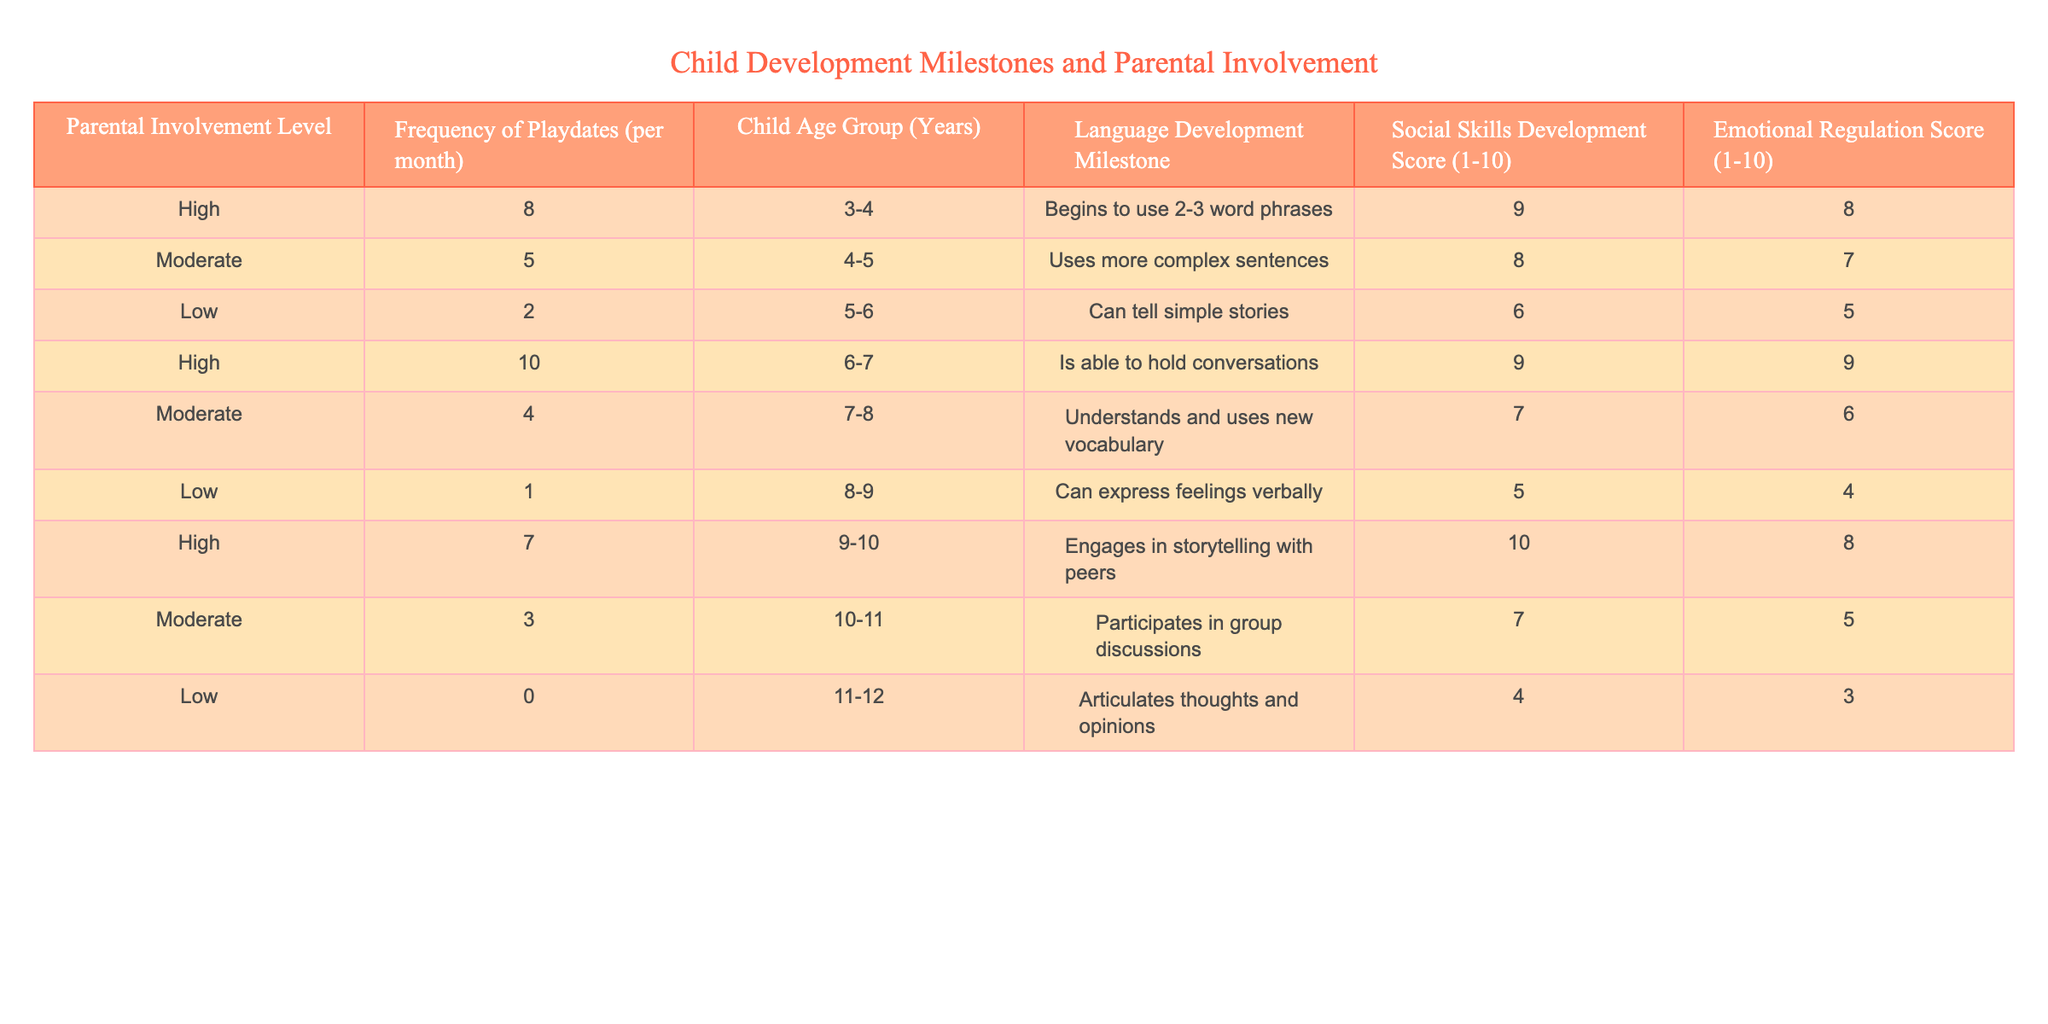What is the highest Social Skills Development Score recorded in the table? The maximum score in the "Social Skills Development Score" column is 10. This value is found in the row where the parental involvement level is "High," the frequency of playdates is 7, and the child age group is 9-10 years.
Answer: 10 What age group has the lowest Emotional Regulation Score? The "Emotional Regulation Score" for the age group 11-12, with low parental involvement and 0 playdates, is 3. This is the lowest score across all age groups in the table.
Answer: 3 What is the average frequency of playdates for children in the 3-4 age group? There is one entry for the 3-4 age group with 8 playdates per month. Therefore, the average is 8 since there's only one data point present.
Answer: 8 Did children with high parental involvement consistently have higher scores in language development compared to those with low involvement? Yes, children with high parental involvement had language development milestones such as using 2-3 word phrases and holding conversations, while those with low involvement showed lower milestones: they can only tell simple stories or express feelings verbally.
Answer: Yes What is the total number of playdates recorded for children in the 4-5 age group? There is one entry for the 4-5 age group with a frequency of 5 playdates per month. Therefore, the total for this age group is simply 5 playdates.
Answer: 5 What was the average Emotional Regulation Score for the moderate parental involvement level? The Emotional Regulation Scores for moderate involvement are 7, 6, and 5. Summing these gives 7 + 6 + 5 = 18, and dividing by the total data points (3) yields an average of 18/3 = 6.
Answer: 6 How many children in the 6-7 age range were noted to have high parental involvement? There is one record for the 6-7 age group marked as high parental involvement, which is for a child with 10 playdates.
Answer: 1 What is the difference in Social Skills Development Score between children with high and low parental involvement? The average Social Skills Development Score for high involvement is (9 + 10 + 8) / 3 = 9. The average score for low involvement is (6 + 5 + 4) / 3 = 5. The difference is 9 - 5 = 4.
Answer: 4 What proportion of children in the table achieved a language development milestone of "Can express feelings verbally"? The phrase "Can express feelings verbally" corresponds to the child in the 8-9 age group with low parental involvement. Thus, there is 1 occurrence out of 9 total records, which equals 1/9 ≈ 0.11, or about 11%.
Answer: 11% 